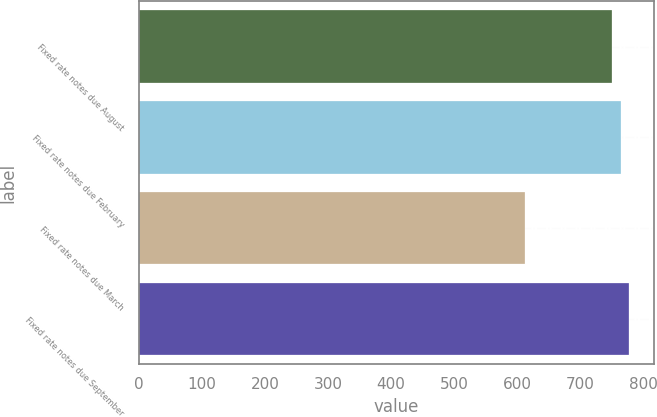<chart> <loc_0><loc_0><loc_500><loc_500><bar_chart><fcel>Fixed rate notes due August<fcel>Fixed rate notes due February<fcel>Fixed rate notes due March<fcel>Fixed rate notes due September<nl><fcel>750<fcel>763.75<fcel>612.5<fcel>777.5<nl></chart> 